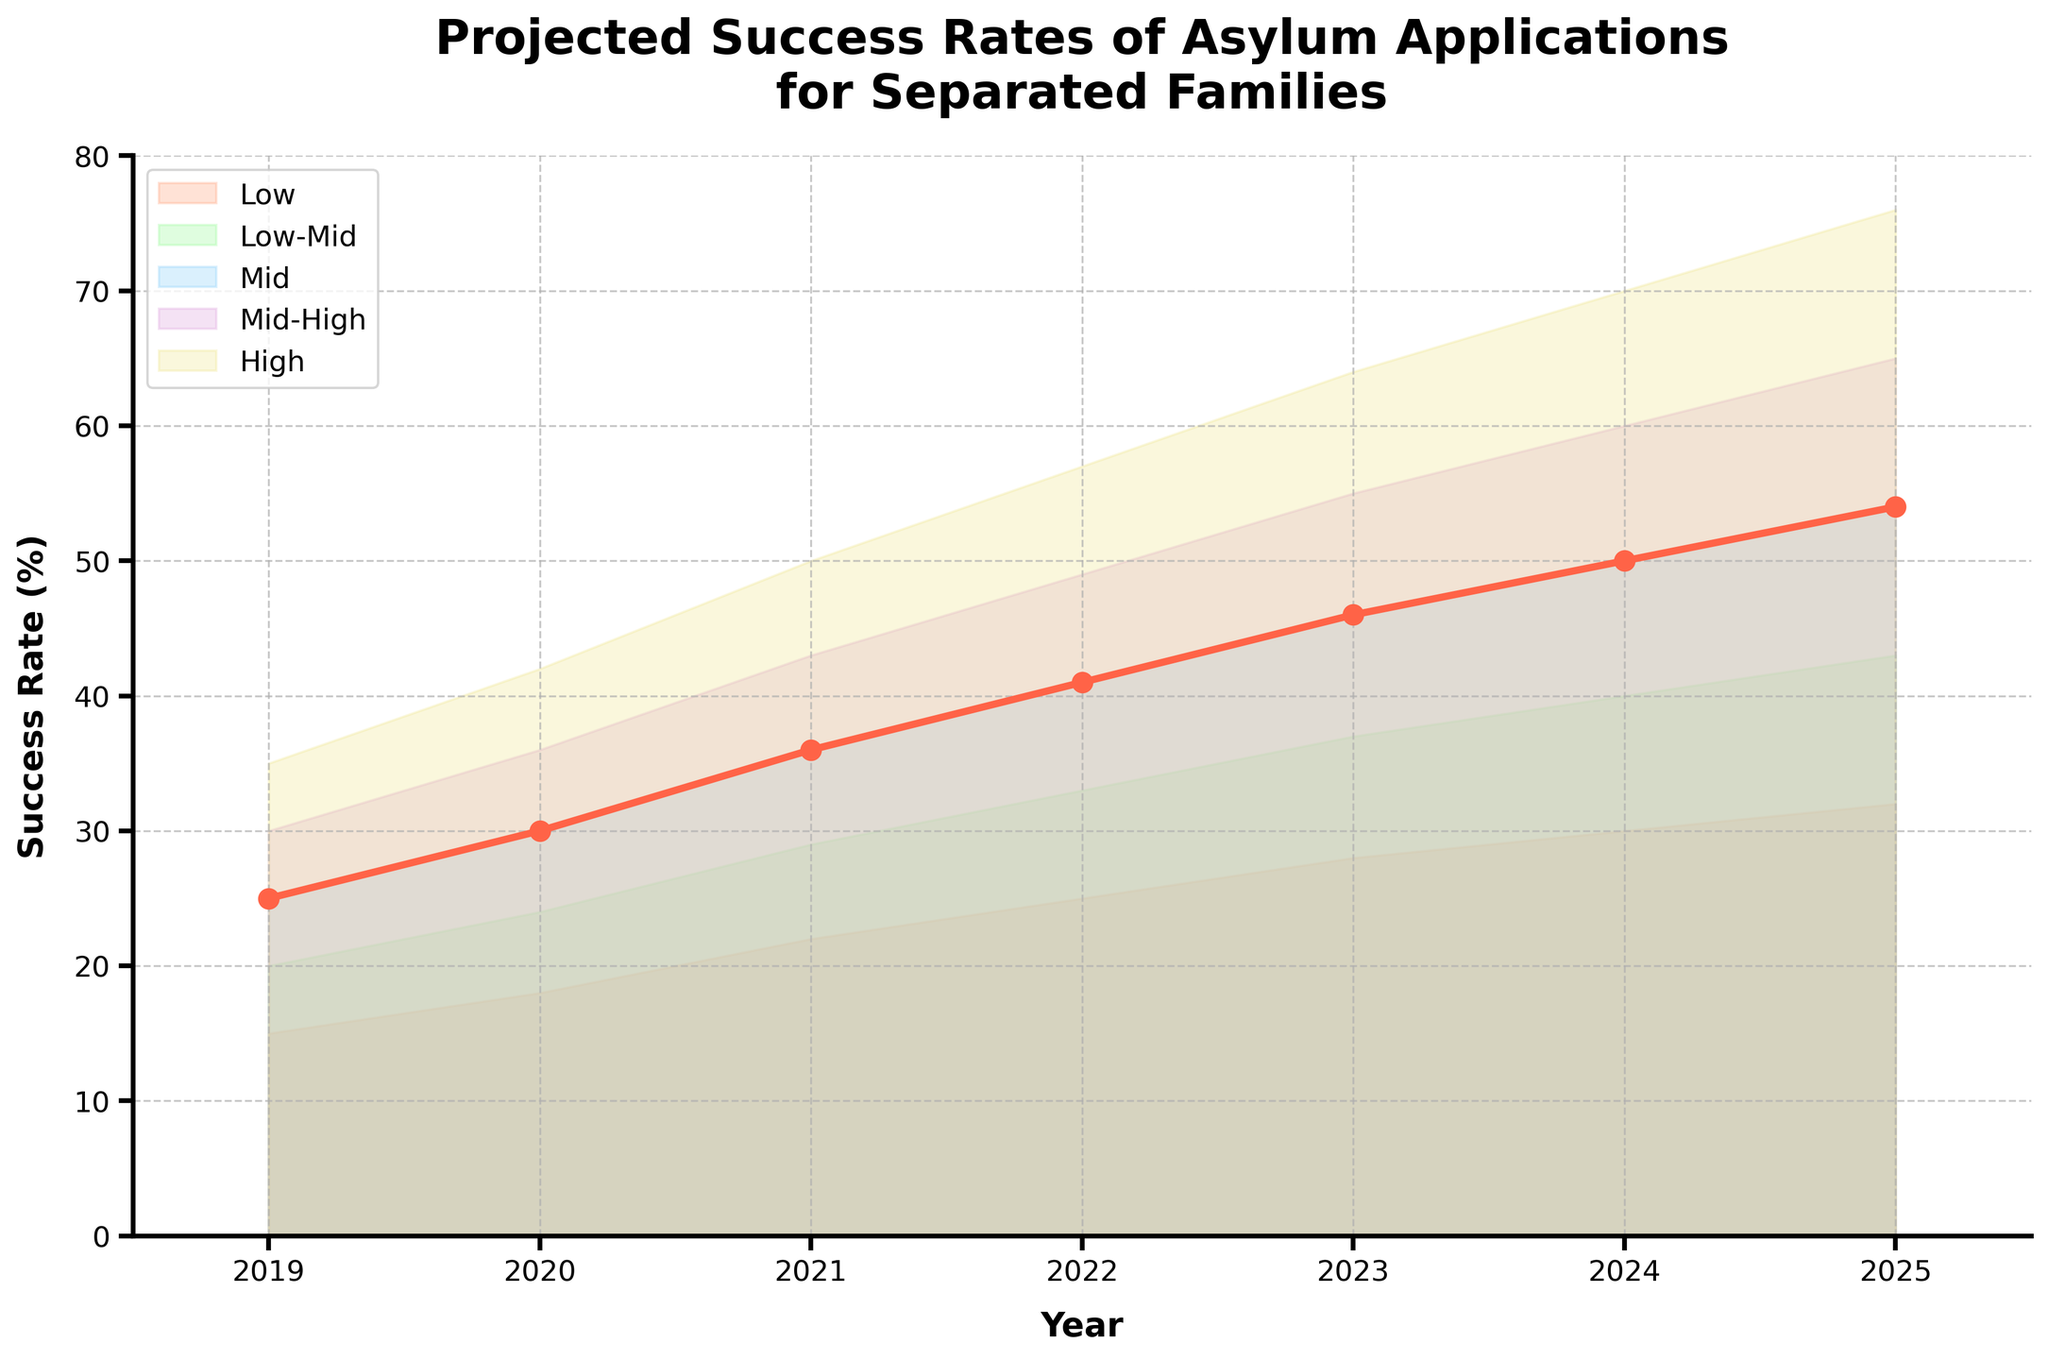What is the lowest projected success rate in 2023? From the chart, for the year 2023, the lowest success rate is represented by the bottom edge of the shaded areas from that year. It is labeled 'Low' and has a value of 28.
Answer: 28 What are the colors representing different projection intervals for the success rates? The chart uses distinct colors for each projection interval. From bottom to top, they are soft orange, light green, sky blue, plum purple, and pale yellow.
Answer: Soft orange, light green, sky blue, plum purple, pale yellow How does the median projected success rate change from 2019 to 2025? By observing the middle line labeled 'Mid', which uses a distinct color (red), one can note its values from 25 in 2019 to 54 in 2025. Calculating the difference: 54 - 25 = 29. The median projected success rate increases by 29 points.
Answer: 29 points increase What is the projected success rate range (from low to high) for 2024? For the year 2024, the chart shows ranges for projected success rates. The 'Low' is 30, and the 'High' is 70. Subtracting the 'Low' from the 'High' gives the range: 70 - 30 = 40.
Answer: 40 In which year does the 'Mid' value first surpass 40? By examining the 'Mid' line values over the years, we see that 41 appears first in 2022.
Answer: 2022 How much did the highest projected success rate increase from 2019 to 2025? The highest projected rates can be observed for 2019 as 35 and for 2025 as 76. The increase is calculated by subtracting 35 from 76: 76 - 35 = 41.
Answer: 41 What is the average 'High' projected success rate across all years? The values for 'High' from 2019 to 2025 are: 35, 42, 50, 57, 64, 70, 76. Summing up these values: 35 + 42 + 50 + 57 + 64 + 70 + 76 = 394. Dividing by the number of years (7), the average is 394 / 7 ≈ 56.3.
Answer: 56.3 By how much does the projected success rate in the 'Low-Mid' interval rise from 2020 to 2023? The 'Low-Mid' values for 2023 and 2020 are 37 and 24, respectively. The rise is calculated by subtracting 24 from 37: 37 - 24 = 13.
Answer: 13 